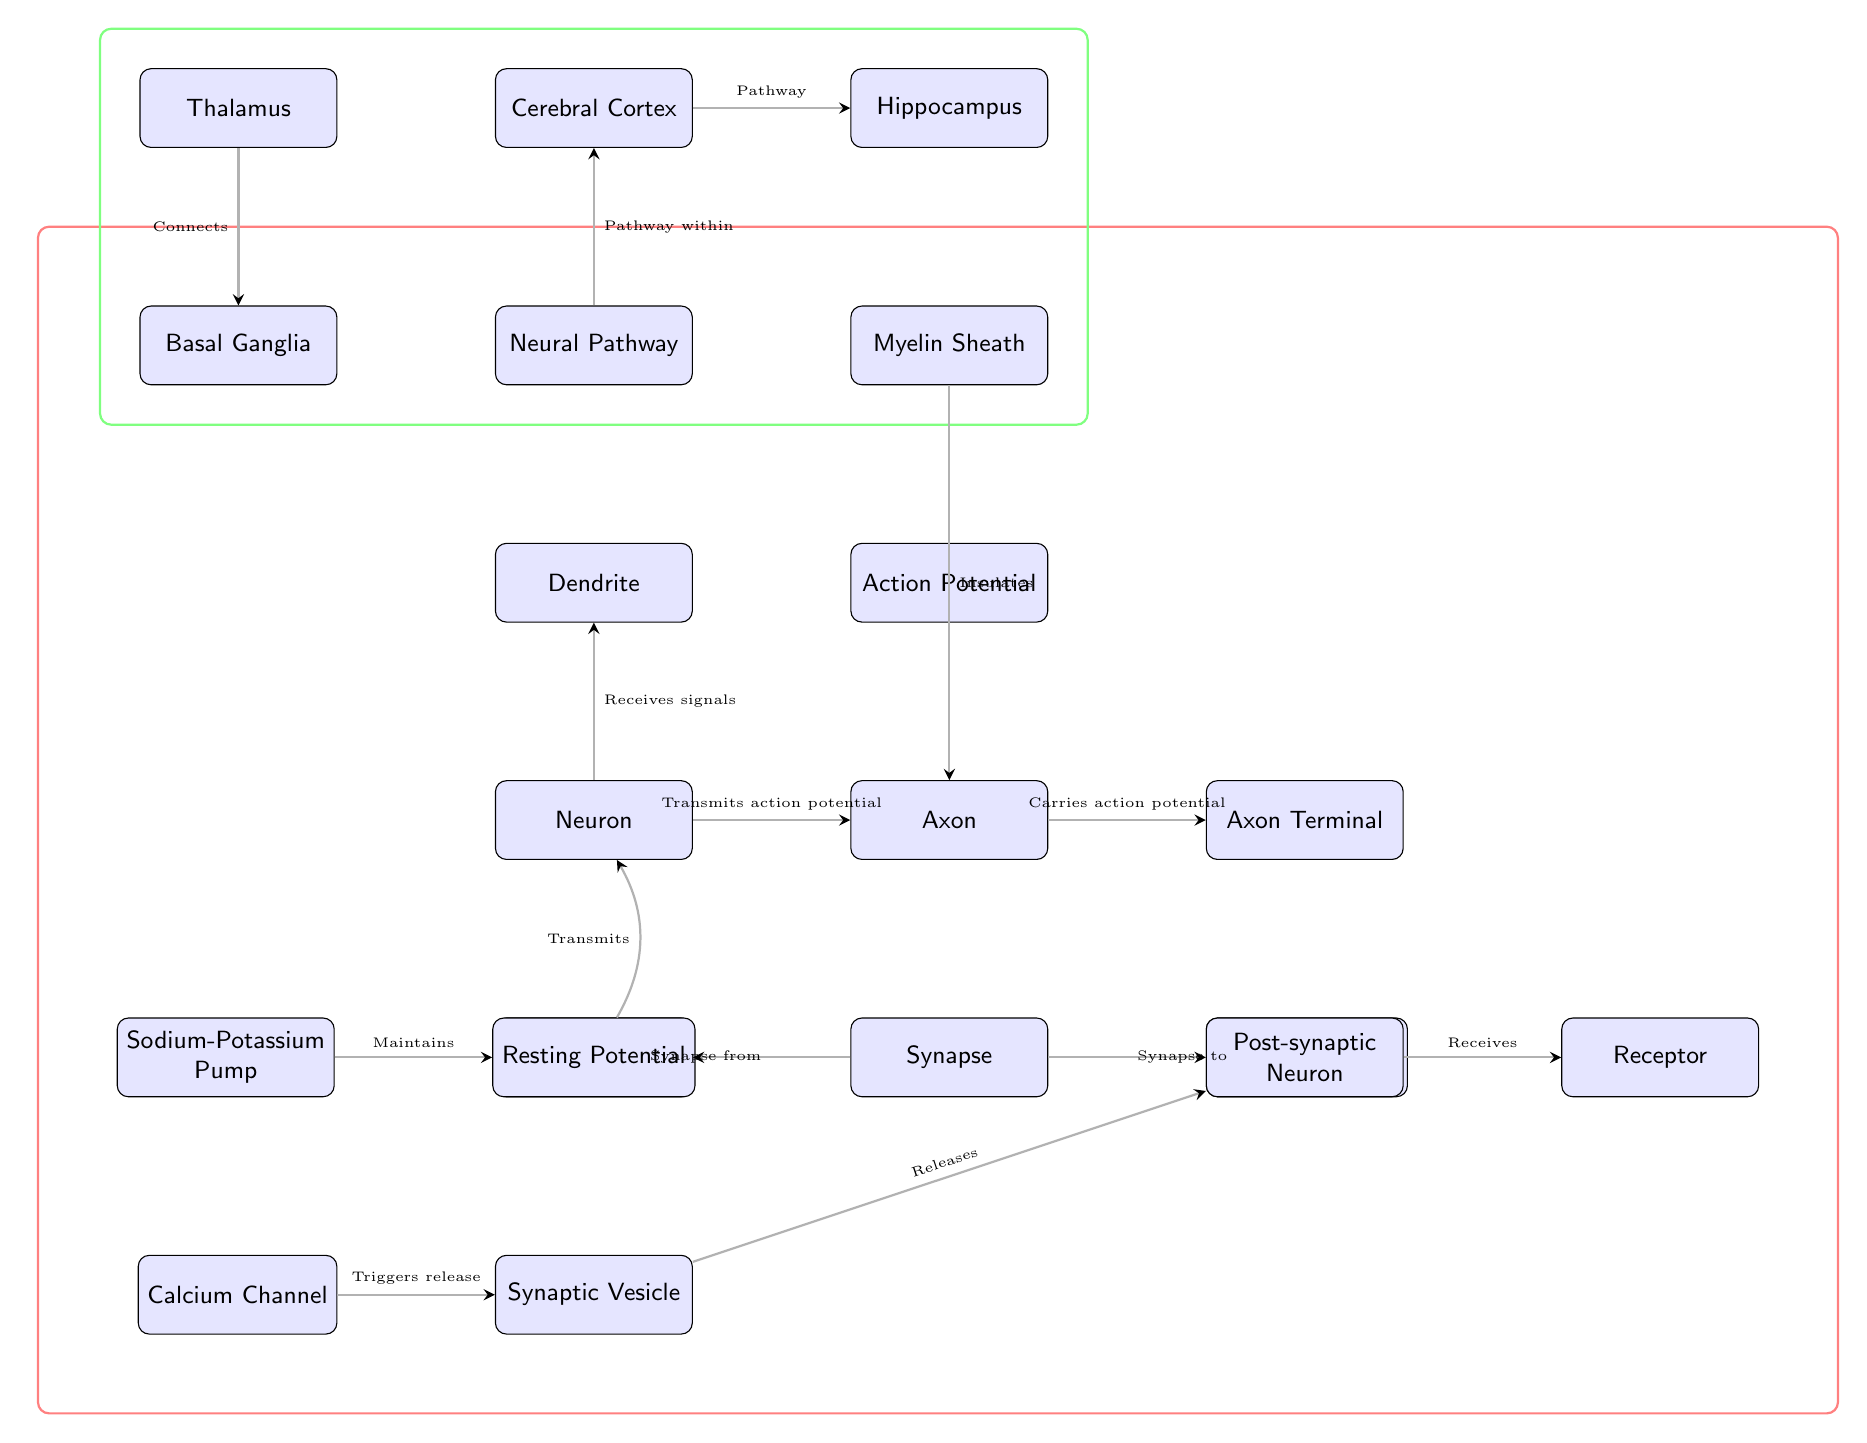What is the central node labeled in the diagram? The central node in the diagram is labeled as "Neuron," which acts as the primary communication point in the neuronal communication pathway.
Answer: Neuron How many layers or types of neurons are represented in the diagram? The diagram represents three layers or types of neurons: Pre-synaptic Neuron, Neuron, and Post-synaptic Neuron. These nodes illustrate the various connections involved in neuronal communication.
Answer: Three What does the "Synaptic Vesicle" release? The "Synaptic Vesicle" releases "Neurotransmitter," which is crucial for transmitting signals across the synapse from the pre-synaptic neuron to the post-synaptic neuron.
Answer: Neurotransmitter What role does the "Calcium Channel" play in the diagram? The "Calcium Channel" triggers the release of "Synaptic Vesicle," which in turn is responsible for the release of neurotransmitters necessary for communication between neurons.
Answer: Triggers release Which node is responsible for maintaining the "Resting Potential"? The "Sodium-Potassium Pump" is responsible for maintaining the "Resting Potential," ensuring that the neuron is prepared for subsequent action potentials and signaling.
Answer: Sodium-Potassium Pump In which direction does the "Axon" carry the action potential? The "Axon" carries the action potential towards the "Axon Terminal," where neurotransmitters are released to communicate with the next neuron in the pathway.
Answer: Towards the Axon Terminal What connects the "Cerebral Cortex" and "Hippocampus"? The "Neural Pathway" connects the "Cerebral Cortex" and "Hippocampus," highlighting their interrelations within the brain's structure.
Answer: Pathway How many total nodes are present in the diagram? The diagram includes a total of twenty nodes, each representing different components or concepts related to neuronal communication pathways.
Answer: Twenty 